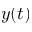Convert formula to latex. <formula><loc_0><loc_0><loc_500><loc_500>y ( t )</formula> 